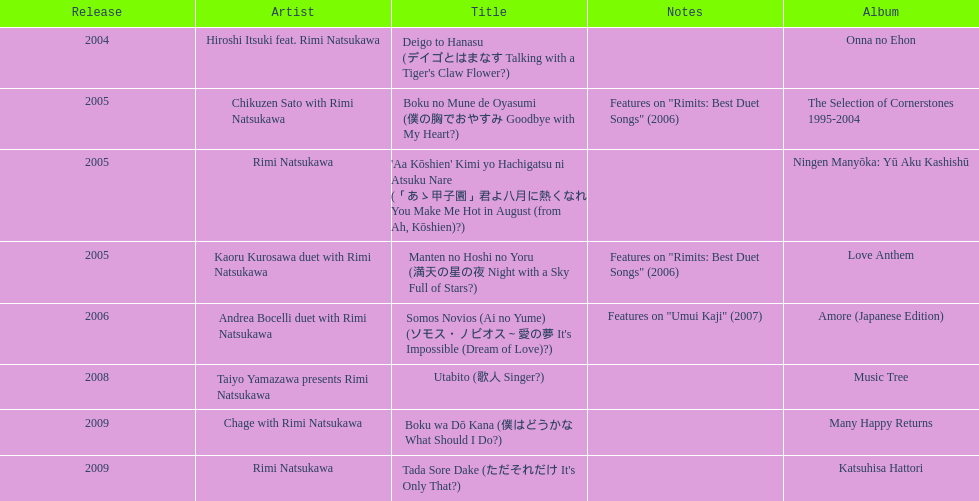Write the full table. {'header': ['Release', 'Artist', 'Title', 'Notes', 'Album'], 'rows': [['2004', 'Hiroshi Itsuki feat. Rimi Natsukawa', "Deigo to Hanasu (デイゴとはまなす Talking with a Tiger's Claw Flower?)", '', 'Onna no Ehon'], ['2005', 'Chikuzen Sato with Rimi Natsukawa', 'Boku no Mune de Oyasumi (僕の胸でおやすみ Goodbye with My Heart?)', 'Features on "Rimits: Best Duet Songs" (2006)', 'The Selection of Cornerstones 1995-2004'], ['2005', 'Rimi Natsukawa', "'Aa Kōshien' Kimi yo Hachigatsu ni Atsuku Nare (「あゝ甲子園」君よ八月に熱くなれ You Make Me Hot in August (from Ah, Kōshien)?)", '', 'Ningen Manyōka: Yū Aku Kashishū'], ['2005', 'Kaoru Kurosawa duet with Rimi Natsukawa', 'Manten no Hoshi no Yoru (満天の星の夜 Night with a Sky Full of Stars?)', 'Features on "Rimits: Best Duet Songs" (2006)', 'Love Anthem'], ['2006', 'Andrea Bocelli duet with Rimi Natsukawa', "Somos Novios (Ai no Yume) (ソモス・ノビオス～愛の夢 It's Impossible (Dream of Love)?)", 'Features on "Umui Kaji" (2007)', 'Amore (Japanese Edition)'], ['2008', 'Taiyo Yamazawa presents Rimi Natsukawa', 'Utabito (歌人 Singer?)', '', 'Music Tree'], ['2009', 'Chage with Rimi Natsukawa', 'Boku wa Dō Kana (僕はどうかな What Should I Do?)', '', 'Many Happy Returns'], ['2009', 'Rimi Natsukawa', "Tada Sore Dake (ただそれだけ It's Only That?)", '', 'Katsuhisa Hattori']]} What is the quantity of albums published in collaboration with the artist rimi natsukawa? 8. 